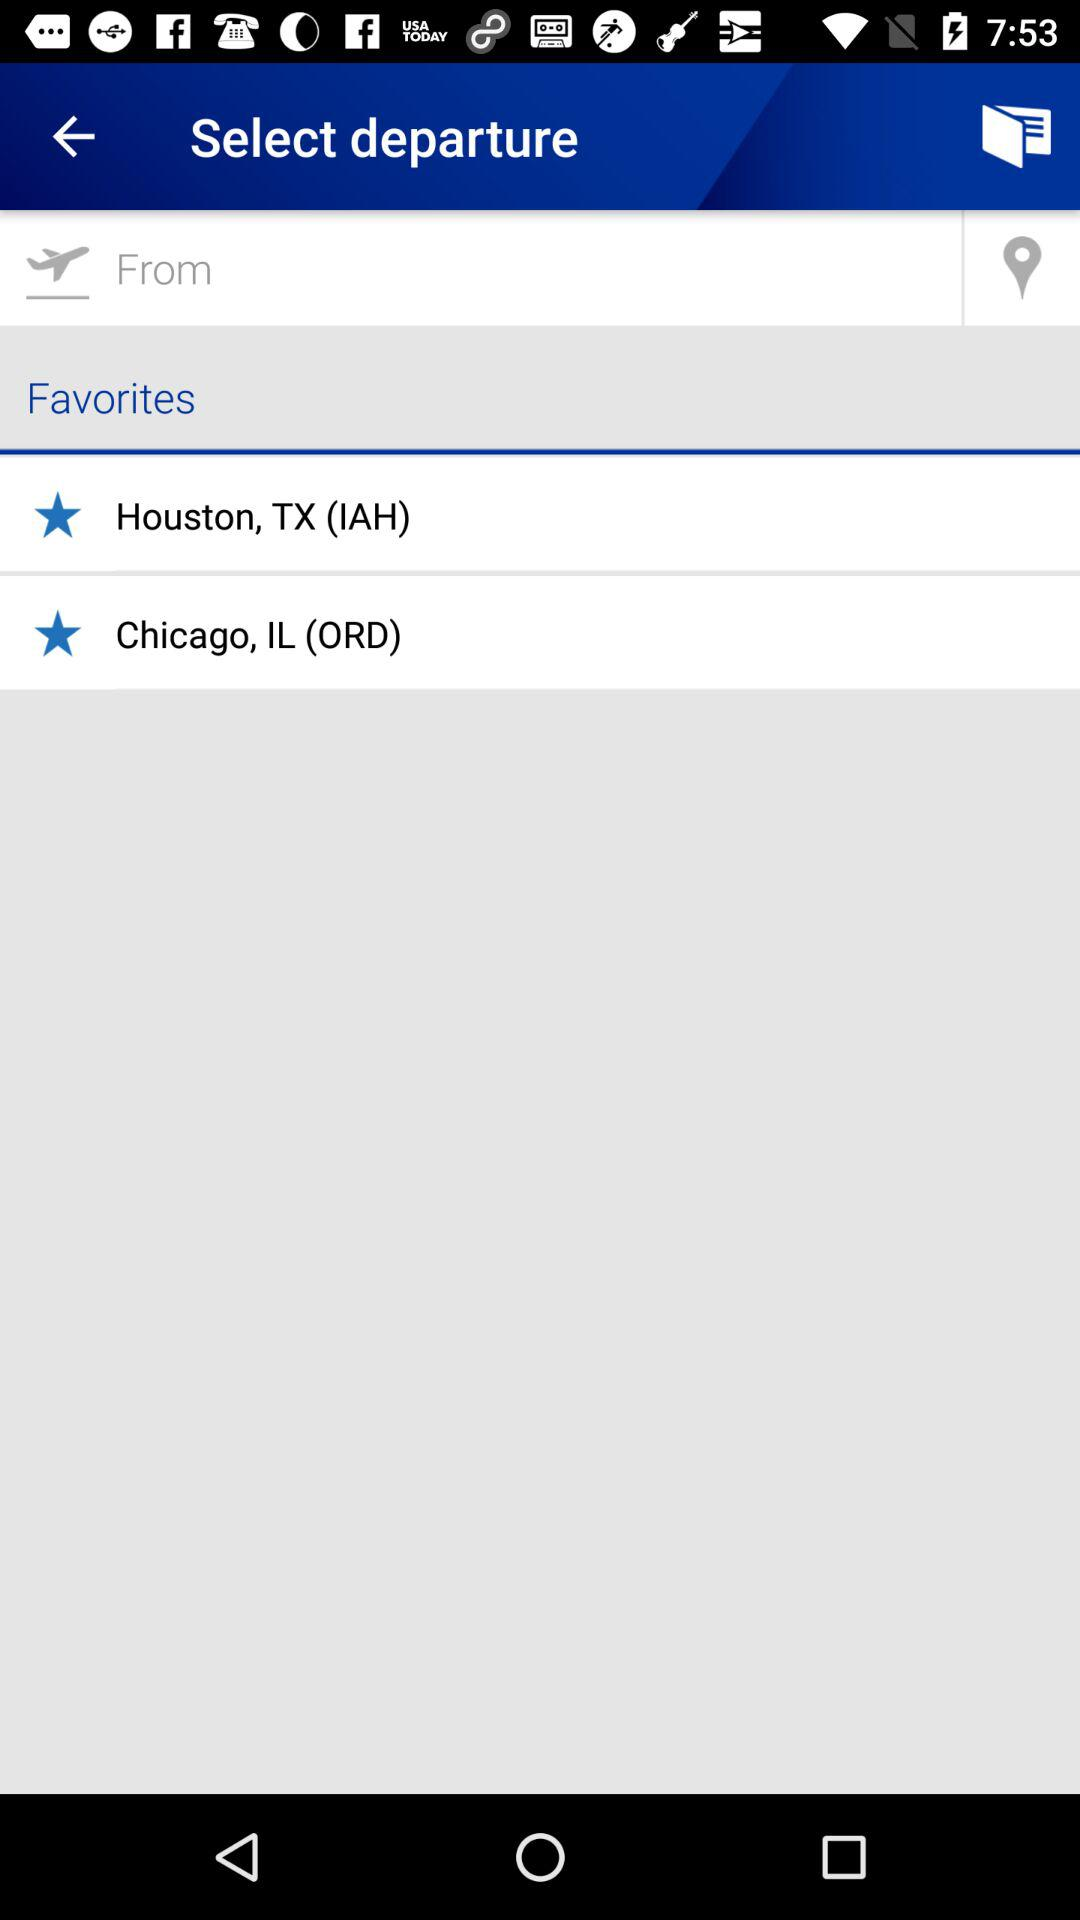How many favorites are there?
Answer the question using a single word or phrase. 2 